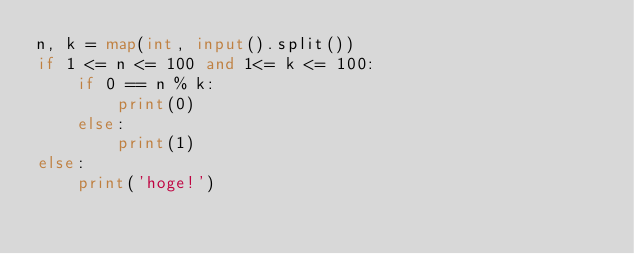<code> <loc_0><loc_0><loc_500><loc_500><_Python_>n, k = map(int, input().split())
if 1 <= n <= 100 and 1<= k <= 100:
    if 0 == n % k:
        print(0)
    else:
        print(1)
else:
    print('hoge!')</code> 